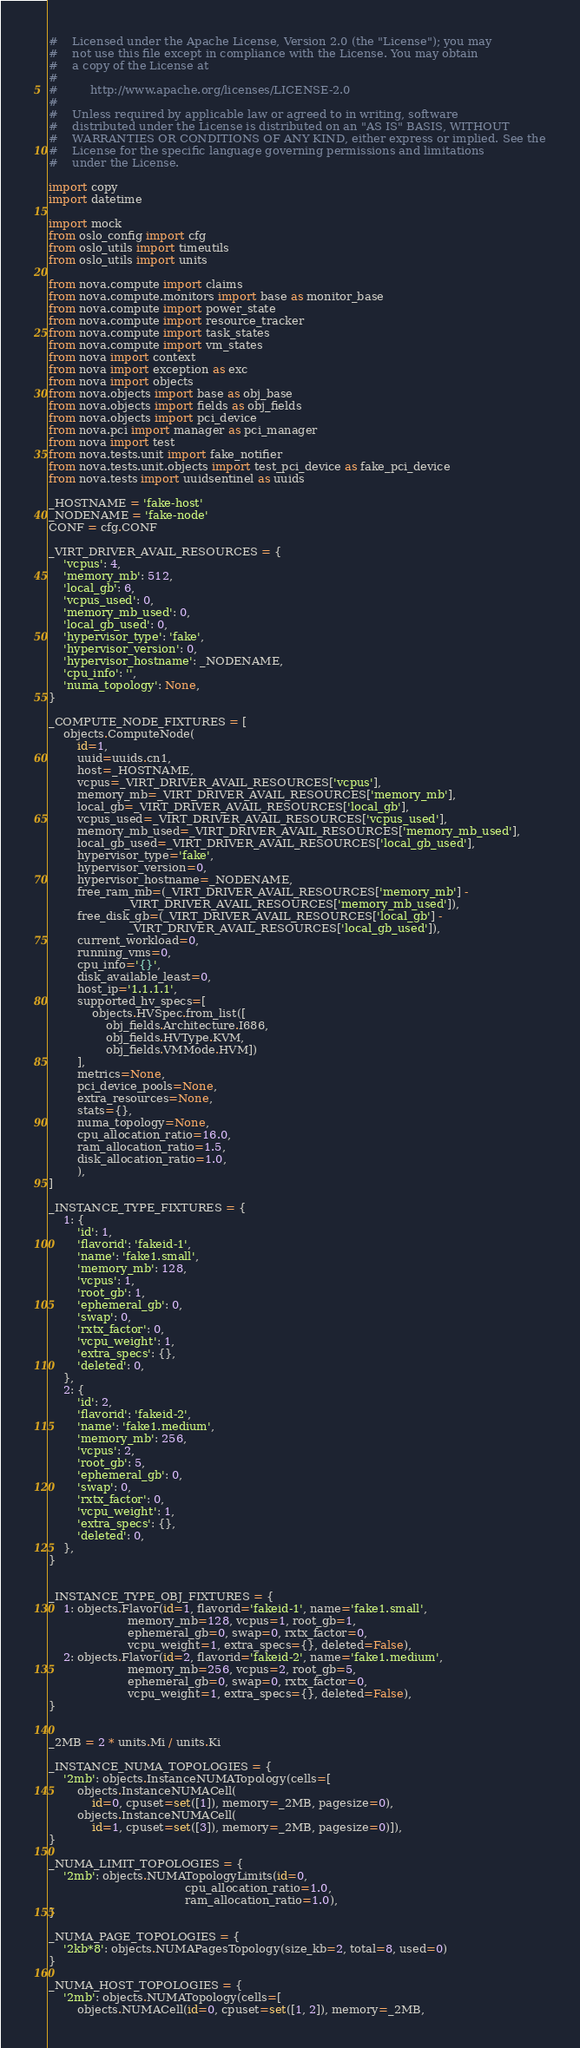<code> <loc_0><loc_0><loc_500><loc_500><_Python_>#    Licensed under the Apache License, Version 2.0 (the "License"); you may
#    not use this file except in compliance with the License. You may obtain
#    a copy of the License at
#
#         http://www.apache.org/licenses/LICENSE-2.0
#
#    Unless required by applicable law or agreed to in writing, software
#    distributed under the License is distributed on an "AS IS" BASIS, WITHOUT
#    WARRANTIES OR CONDITIONS OF ANY KIND, either express or implied. See the
#    License for the specific language governing permissions and limitations
#    under the License.

import copy
import datetime

import mock
from oslo_config import cfg
from oslo_utils import timeutils
from oslo_utils import units

from nova.compute import claims
from nova.compute.monitors import base as monitor_base
from nova.compute import power_state
from nova.compute import resource_tracker
from nova.compute import task_states
from nova.compute import vm_states
from nova import context
from nova import exception as exc
from nova import objects
from nova.objects import base as obj_base
from nova.objects import fields as obj_fields
from nova.objects import pci_device
from nova.pci import manager as pci_manager
from nova import test
from nova.tests.unit import fake_notifier
from nova.tests.unit.objects import test_pci_device as fake_pci_device
from nova.tests import uuidsentinel as uuids

_HOSTNAME = 'fake-host'
_NODENAME = 'fake-node'
CONF = cfg.CONF

_VIRT_DRIVER_AVAIL_RESOURCES = {
    'vcpus': 4,
    'memory_mb': 512,
    'local_gb': 6,
    'vcpus_used': 0,
    'memory_mb_used': 0,
    'local_gb_used': 0,
    'hypervisor_type': 'fake',
    'hypervisor_version': 0,
    'hypervisor_hostname': _NODENAME,
    'cpu_info': '',
    'numa_topology': None,
}

_COMPUTE_NODE_FIXTURES = [
    objects.ComputeNode(
        id=1,
        uuid=uuids.cn1,
        host=_HOSTNAME,
        vcpus=_VIRT_DRIVER_AVAIL_RESOURCES['vcpus'],
        memory_mb=_VIRT_DRIVER_AVAIL_RESOURCES['memory_mb'],
        local_gb=_VIRT_DRIVER_AVAIL_RESOURCES['local_gb'],
        vcpus_used=_VIRT_DRIVER_AVAIL_RESOURCES['vcpus_used'],
        memory_mb_used=_VIRT_DRIVER_AVAIL_RESOURCES['memory_mb_used'],
        local_gb_used=_VIRT_DRIVER_AVAIL_RESOURCES['local_gb_used'],
        hypervisor_type='fake',
        hypervisor_version=0,
        hypervisor_hostname=_NODENAME,
        free_ram_mb=(_VIRT_DRIVER_AVAIL_RESOURCES['memory_mb'] -
                     _VIRT_DRIVER_AVAIL_RESOURCES['memory_mb_used']),
        free_disk_gb=(_VIRT_DRIVER_AVAIL_RESOURCES['local_gb'] -
                      _VIRT_DRIVER_AVAIL_RESOURCES['local_gb_used']),
        current_workload=0,
        running_vms=0,
        cpu_info='{}',
        disk_available_least=0,
        host_ip='1.1.1.1',
        supported_hv_specs=[
            objects.HVSpec.from_list([
                obj_fields.Architecture.I686,
                obj_fields.HVType.KVM,
                obj_fields.VMMode.HVM])
        ],
        metrics=None,
        pci_device_pools=None,
        extra_resources=None,
        stats={},
        numa_topology=None,
        cpu_allocation_ratio=16.0,
        ram_allocation_ratio=1.5,
        disk_allocation_ratio=1.0,
        ),
]

_INSTANCE_TYPE_FIXTURES = {
    1: {
        'id': 1,
        'flavorid': 'fakeid-1',
        'name': 'fake1.small',
        'memory_mb': 128,
        'vcpus': 1,
        'root_gb': 1,
        'ephemeral_gb': 0,
        'swap': 0,
        'rxtx_factor': 0,
        'vcpu_weight': 1,
        'extra_specs': {},
        'deleted': 0,
    },
    2: {
        'id': 2,
        'flavorid': 'fakeid-2',
        'name': 'fake1.medium',
        'memory_mb': 256,
        'vcpus': 2,
        'root_gb': 5,
        'ephemeral_gb': 0,
        'swap': 0,
        'rxtx_factor': 0,
        'vcpu_weight': 1,
        'extra_specs': {},
        'deleted': 0,
    },
}


_INSTANCE_TYPE_OBJ_FIXTURES = {
    1: objects.Flavor(id=1, flavorid='fakeid-1', name='fake1.small',
                      memory_mb=128, vcpus=1, root_gb=1,
                      ephemeral_gb=0, swap=0, rxtx_factor=0,
                      vcpu_weight=1, extra_specs={}, deleted=False),
    2: objects.Flavor(id=2, flavorid='fakeid-2', name='fake1.medium',
                      memory_mb=256, vcpus=2, root_gb=5,
                      ephemeral_gb=0, swap=0, rxtx_factor=0,
                      vcpu_weight=1, extra_specs={}, deleted=False),
}


_2MB = 2 * units.Mi / units.Ki

_INSTANCE_NUMA_TOPOLOGIES = {
    '2mb': objects.InstanceNUMATopology(cells=[
        objects.InstanceNUMACell(
            id=0, cpuset=set([1]), memory=_2MB, pagesize=0),
        objects.InstanceNUMACell(
            id=1, cpuset=set([3]), memory=_2MB, pagesize=0)]),
}

_NUMA_LIMIT_TOPOLOGIES = {
    '2mb': objects.NUMATopologyLimits(id=0,
                                      cpu_allocation_ratio=1.0,
                                      ram_allocation_ratio=1.0),
}

_NUMA_PAGE_TOPOLOGIES = {
    '2kb*8': objects.NUMAPagesTopology(size_kb=2, total=8, used=0)
}

_NUMA_HOST_TOPOLOGIES = {
    '2mb': objects.NUMATopology(cells=[
        objects.NUMACell(id=0, cpuset=set([1, 2]), memory=_2MB,</code> 